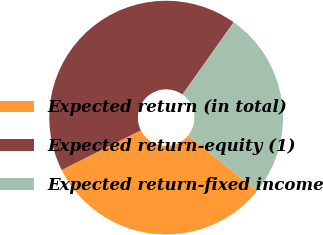Convert chart to OTSL. <chart><loc_0><loc_0><loc_500><loc_500><pie_chart><fcel>Expected return (in total)<fcel>Expected return-equity (1)<fcel>Expected return-fixed income<nl><fcel>31.79%<fcel>42.2%<fcel>26.01%<nl></chart> 